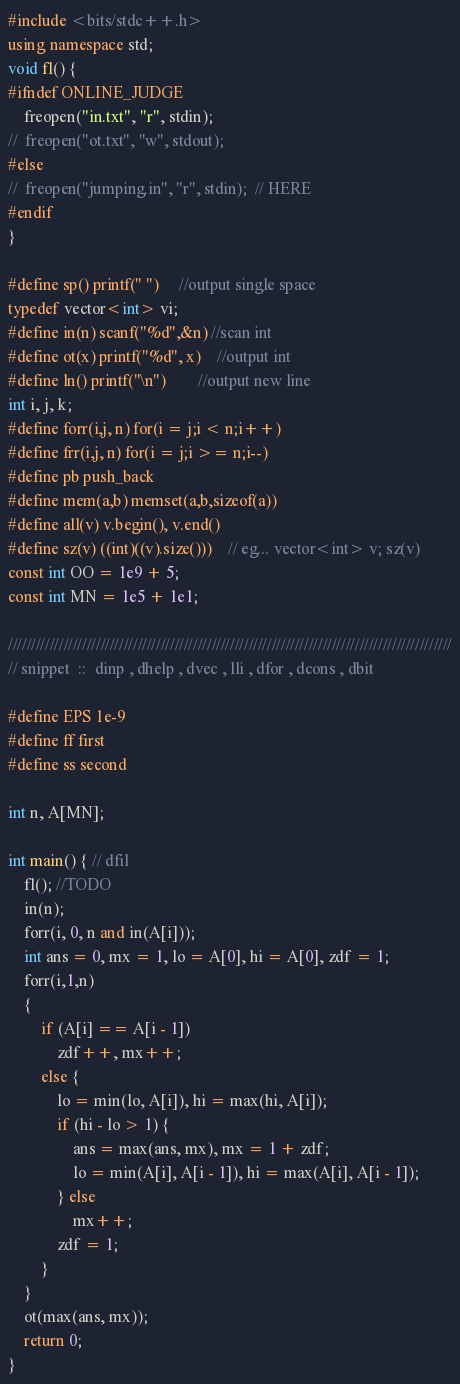<code> <loc_0><loc_0><loc_500><loc_500><_C++_>#include <bits/stdc++.h>
using namespace std;
void fl() {
#ifndef ONLINE_JUDGE
	freopen("in.txt", "r", stdin);
//	freopen("ot.txt", "w", stdout);
#else
//	freopen("jumping.in", "r", stdin);	// HERE
#endif
}

#define sp() printf(" ")		//output single space
typedef vector<int> vi;
#define in(n) scanf("%d",&n)	//scan int
#define ot(x) printf("%d", x)	//output int
#define ln() printf("\n")		//output new line
int i, j, k;
#define forr(i,j, n) for(i = j;i < n;i++)
#define frr(i,j, n) for(i = j;i >= n;i--)
#define pb push_back
#define mem(a,b) memset(a,b,sizeof(a))
#define all(v) v.begin(), v.end()
#define sz(v) ((int)((v).size()))	// eg... vector<int> v; sz(v)
const int OO = 1e9 + 5;
const int MN = 1e5 + 1e1;

////////////////////////////////////////////////////////////////////////////////////////////////
// snippet  ::  dinp , dhelp , dvec , lli , dfor , dcons , dbit

#define EPS 1e-9
#define ff first
#define ss second

int n, A[MN];

int main() { // dfil
	fl(); //TODO
	in(n);
	forr(i, 0, n and in(A[i]));
	int ans = 0, mx = 1, lo = A[0], hi = A[0], zdf = 1;
	forr(i,1,n)
	{
		if (A[i] == A[i - 1])
			zdf++, mx++;
		else {
			lo = min(lo, A[i]), hi = max(hi, A[i]);
			if (hi - lo > 1) {
				ans = max(ans, mx), mx = 1 + zdf;
				lo = min(A[i], A[i - 1]), hi = max(A[i], A[i - 1]);
			} else
				mx++;
			zdf = 1;
		}
	}
	ot(max(ans, mx));
	return 0;
}
</code> 